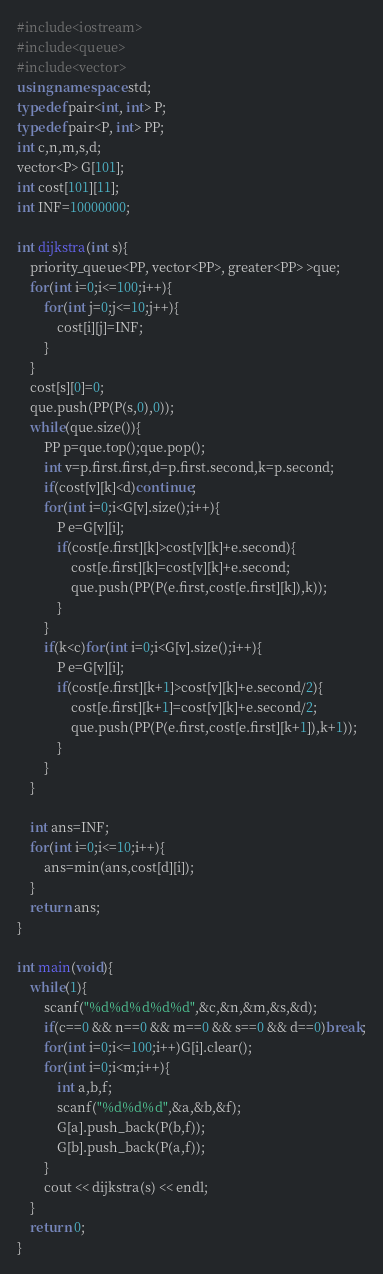Convert code to text. <code><loc_0><loc_0><loc_500><loc_500><_C++_>#include<iostream>
#include<queue>
#include<vector>
using namespace std;
typedef pair<int, int> P;
typedef pair<P, int> PP;
int c,n,m,s,d;
vector<P> G[101];
int cost[101][11];
int INF=10000000;

int dijkstra(int s){
	priority_queue<PP, vector<PP>, greater<PP> >que;
	for(int i=0;i<=100;i++){
		for(int j=0;j<=10;j++){
			cost[i][j]=INF;
		}
	}
	cost[s][0]=0;
	que.push(PP(P(s,0),0));
	while(que.size()){
		PP p=que.top();que.pop();
		int v=p.first.first,d=p.first.second,k=p.second;
		if(cost[v][k]<d)continue;
		for(int i=0;i<G[v].size();i++){
			P e=G[v][i];
			if(cost[e.first][k]>cost[v][k]+e.second){
				cost[e.first][k]=cost[v][k]+e.second;
				que.push(PP(P(e.first,cost[e.first][k]),k));
			}
		}
		if(k<c)for(int i=0;i<G[v].size();i++){
			P e=G[v][i];
			if(cost[e.first][k+1]>cost[v][k]+e.second/2){
				cost[e.first][k+1]=cost[v][k]+e.second/2;
				que.push(PP(P(e.first,cost[e.first][k+1]),k+1));
			}
		}
	}

	int ans=INF;
	for(int i=0;i<=10;i++){
		ans=min(ans,cost[d][i]);
	}
	return ans;
}

int main(void){
	while(1){
		scanf("%d%d%d%d%d",&c,&n,&m,&s,&d);
		if(c==0 && n==0 && m==0 && s==0 && d==0)break;
		for(int i=0;i<=100;i++)G[i].clear();
		for(int i=0;i<m;i++){
			int a,b,f;
			scanf("%d%d%d",&a,&b,&f);
			G[a].push_back(P(b,f));
			G[b].push_back(P(a,f));
		}
		cout << dijkstra(s) << endl;
	}
    return 0;
}</code> 